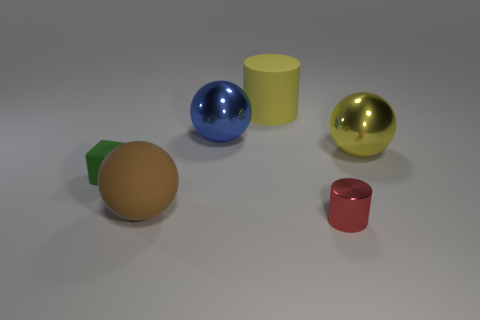There is a large brown object that is the same shape as the blue shiny thing; what is its material? The large brown object resembling the shape of the blue shiny sphere appears to be made out of a matte clay material, which differs from the reflective metal or glass material that the blue sphere seems to be made of. 